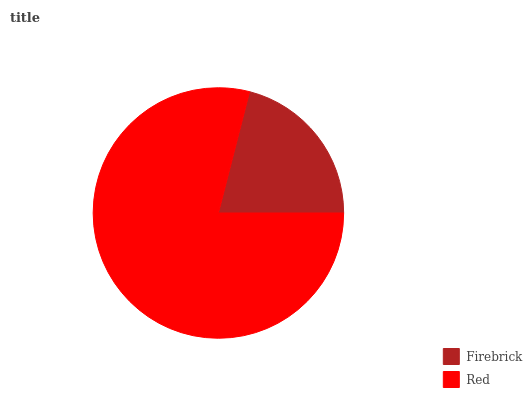Is Firebrick the minimum?
Answer yes or no. Yes. Is Red the maximum?
Answer yes or no. Yes. Is Red the minimum?
Answer yes or no. No. Is Red greater than Firebrick?
Answer yes or no. Yes. Is Firebrick less than Red?
Answer yes or no. Yes. Is Firebrick greater than Red?
Answer yes or no. No. Is Red less than Firebrick?
Answer yes or no. No. Is Red the high median?
Answer yes or no. Yes. Is Firebrick the low median?
Answer yes or no. Yes. Is Firebrick the high median?
Answer yes or no. No. Is Red the low median?
Answer yes or no. No. 